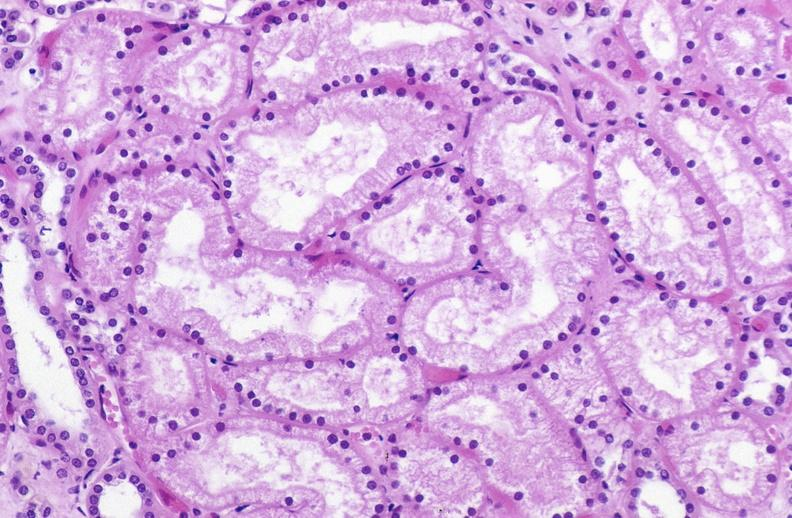does blood show atn acute tubular necrosis?
Answer the question using a single word or phrase. No 